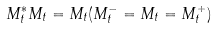<formula> <loc_0><loc_0><loc_500><loc_500>M _ { t } ^ { * } M _ { t } = M _ { t } ( M _ { t } ^ { - } = M _ { t } = M _ { t } ^ { + } )</formula> 